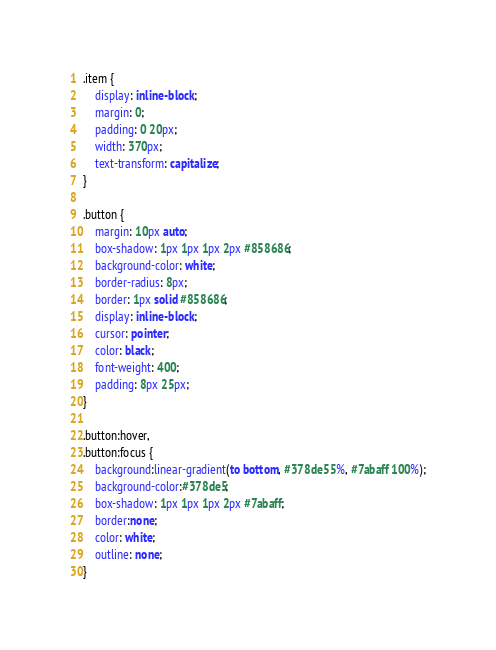Convert code to text. <code><loc_0><loc_0><loc_500><loc_500><_CSS_>.item {
    display: inline-block;
    margin: 0;
    padding: 0 20px;
    width: 370px;
    text-transform: capitalize;
}

.button {
    margin: 10px auto;
    box-shadow: 1px 1px 1px 2px #858686;
    background-color: white;
    border-radius: 8px;
    border: 1px solid #858686;
    display: inline-block;
    cursor: pointer;
    color: black;
    font-weight: 400;
    padding: 8px 25px;
}

.button:hover,
.button:focus {
    background:linear-gradient(to bottom, #378de5 5%, #7abaff 100%);
    background-color:#378de5;
    box-shadow: 1px 1px 1px 2px #7abaff;
    border:none;
    color: white;
    outline: none;
}</code> 